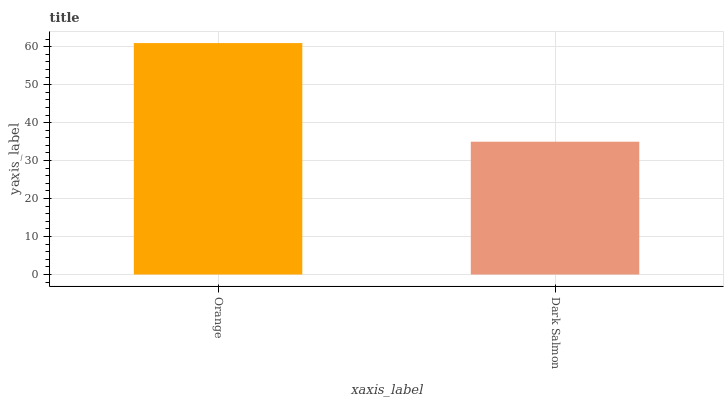Is Dark Salmon the minimum?
Answer yes or no. Yes. Is Orange the maximum?
Answer yes or no. Yes. Is Dark Salmon the maximum?
Answer yes or no. No. Is Orange greater than Dark Salmon?
Answer yes or no. Yes. Is Dark Salmon less than Orange?
Answer yes or no. Yes. Is Dark Salmon greater than Orange?
Answer yes or no. No. Is Orange less than Dark Salmon?
Answer yes or no. No. Is Orange the high median?
Answer yes or no. Yes. Is Dark Salmon the low median?
Answer yes or no. Yes. Is Dark Salmon the high median?
Answer yes or no. No. Is Orange the low median?
Answer yes or no. No. 